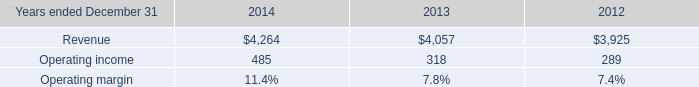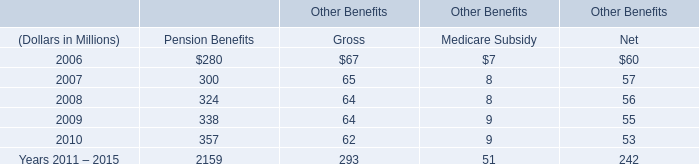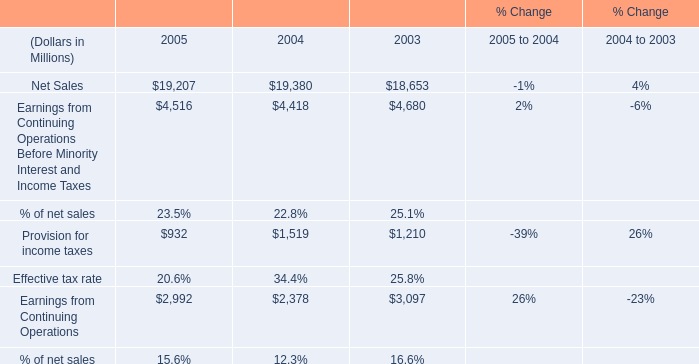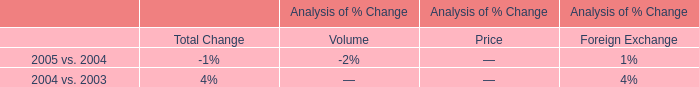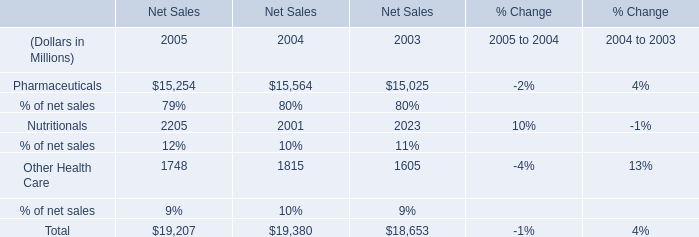if the hr solutions segment generated 35% ( 35 % ) of the consolidated revenue , what would be the total revenue for 2014 , ( in millions ) ? 
Computations: (4264 / 35%)
Answer: 12182.85714. 